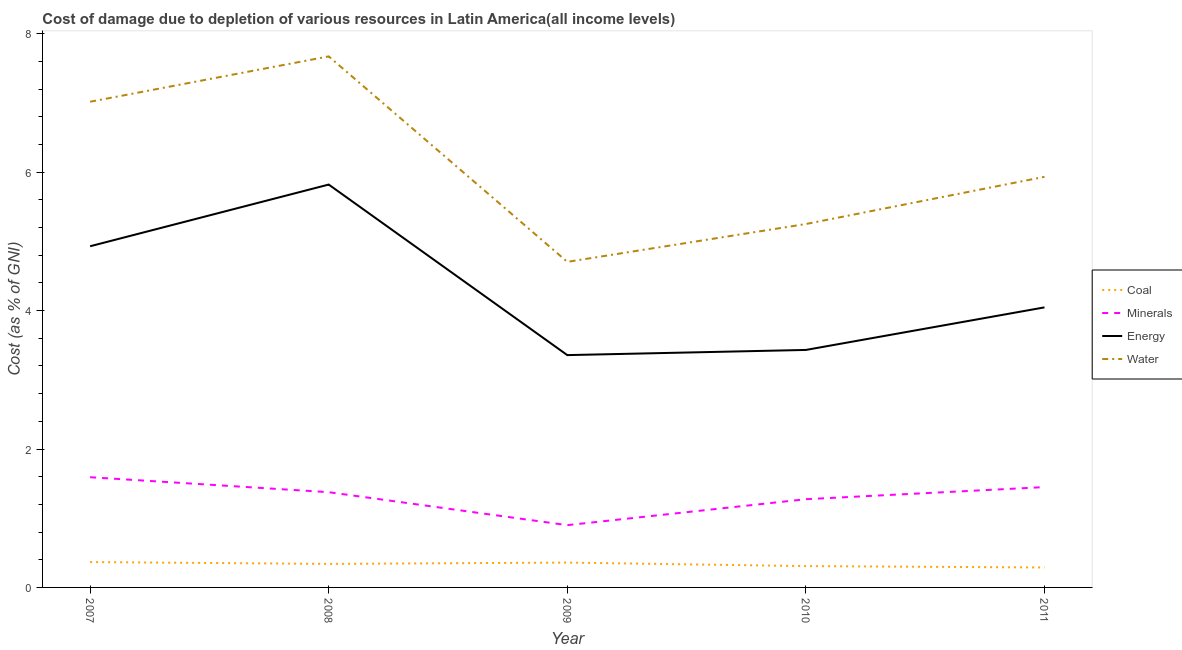How many different coloured lines are there?
Your answer should be very brief. 4. Does the line corresponding to cost of damage due to depletion of water intersect with the line corresponding to cost of damage due to depletion of energy?
Offer a very short reply. No. Is the number of lines equal to the number of legend labels?
Your answer should be compact. Yes. What is the cost of damage due to depletion of energy in 2009?
Offer a very short reply. 3.36. Across all years, what is the maximum cost of damage due to depletion of water?
Offer a terse response. 7.67. Across all years, what is the minimum cost of damage due to depletion of water?
Provide a short and direct response. 4.7. In which year was the cost of damage due to depletion of water minimum?
Make the answer very short. 2009. What is the total cost of damage due to depletion of water in the graph?
Ensure brevity in your answer.  30.58. What is the difference between the cost of damage due to depletion of coal in 2008 and that in 2009?
Your answer should be compact. -0.02. What is the difference between the cost of damage due to depletion of water in 2011 and the cost of damage due to depletion of coal in 2007?
Your answer should be compact. 5.57. What is the average cost of damage due to depletion of water per year?
Your answer should be compact. 6.12. In the year 2008, what is the difference between the cost of damage due to depletion of coal and cost of damage due to depletion of minerals?
Give a very brief answer. -1.04. In how many years, is the cost of damage due to depletion of coal greater than 6.4 %?
Your answer should be very brief. 0. What is the ratio of the cost of damage due to depletion of energy in 2010 to that in 2011?
Provide a succinct answer. 0.85. What is the difference between the highest and the second highest cost of damage due to depletion of energy?
Give a very brief answer. 0.89. What is the difference between the highest and the lowest cost of damage due to depletion of water?
Offer a very short reply. 2.97. In how many years, is the cost of damage due to depletion of coal greater than the average cost of damage due to depletion of coal taken over all years?
Your answer should be compact. 3. Is it the case that in every year, the sum of the cost of damage due to depletion of minerals and cost of damage due to depletion of water is greater than the sum of cost of damage due to depletion of energy and cost of damage due to depletion of coal?
Ensure brevity in your answer.  Yes. Is it the case that in every year, the sum of the cost of damage due to depletion of coal and cost of damage due to depletion of minerals is greater than the cost of damage due to depletion of energy?
Your answer should be very brief. No. Does the cost of damage due to depletion of energy monotonically increase over the years?
Offer a very short reply. No. Is the cost of damage due to depletion of energy strictly less than the cost of damage due to depletion of coal over the years?
Your response must be concise. No. How many lines are there?
Your answer should be very brief. 4. Are the values on the major ticks of Y-axis written in scientific E-notation?
Your answer should be compact. No. Does the graph contain any zero values?
Your answer should be compact. No. Does the graph contain grids?
Provide a succinct answer. No. Where does the legend appear in the graph?
Ensure brevity in your answer.  Center right. How many legend labels are there?
Offer a very short reply. 4. What is the title of the graph?
Provide a short and direct response. Cost of damage due to depletion of various resources in Latin America(all income levels) . Does "Environmental sustainability" appear as one of the legend labels in the graph?
Make the answer very short. No. What is the label or title of the Y-axis?
Your answer should be compact. Cost (as % of GNI). What is the Cost (as % of GNI) in Coal in 2007?
Your response must be concise. 0.37. What is the Cost (as % of GNI) in Minerals in 2007?
Your answer should be very brief. 1.59. What is the Cost (as % of GNI) of Energy in 2007?
Your answer should be very brief. 4.93. What is the Cost (as % of GNI) of Water in 2007?
Offer a terse response. 7.02. What is the Cost (as % of GNI) in Coal in 2008?
Offer a very short reply. 0.34. What is the Cost (as % of GNI) of Minerals in 2008?
Provide a succinct answer. 1.38. What is the Cost (as % of GNI) of Energy in 2008?
Your answer should be compact. 5.82. What is the Cost (as % of GNI) of Water in 2008?
Keep it short and to the point. 7.67. What is the Cost (as % of GNI) in Coal in 2009?
Offer a terse response. 0.36. What is the Cost (as % of GNI) in Minerals in 2009?
Provide a short and direct response. 0.9. What is the Cost (as % of GNI) in Energy in 2009?
Offer a very short reply. 3.36. What is the Cost (as % of GNI) of Water in 2009?
Your answer should be compact. 4.7. What is the Cost (as % of GNI) in Coal in 2010?
Provide a succinct answer. 0.31. What is the Cost (as % of GNI) in Minerals in 2010?
Offer a terse response. 1.27. What is the Cost (as % of GNI) of Energy in 2010?
Ensure brevity in your answer.  3.43. What is the Cost (as % of GNI) of Water in 2010?
Make the answer very short. 5.25. What is the Cost (as % of GNI) in Coal in 2011?
Ensure brevity in your answer.  0.29. What is the Cost (as % of GNI) of Minerals in 2011?
Ensure brevity in your answer.  1.45. What is the Cost (as % of GNI) in Energy in 2011?
Make the answer very short. 4.05. What is the Cost (as % of GNI) of Water in 2011?
Ensure brevity in your answer.  5.93. Across all years, what is the maximum Cost (as % of GNI) in Coal?
Keep it short and to the point. 0.37. Across all years, what is the maximum Cost (as % of GNI) of Minerals?
Ensure brevity in your answer.  1.59. Across all years, what is the maximum Cost (as % of GNI) in Energy?
Provide a short and direct response. 5.82. Across all years, what is the maximum Cost (as % of GNI) of Water?
Provide a succinct answer. 7.67. Across all years, what is the minimum Cost (as % of GNI) in Coal?
Your response must be concise. 0.29. Across all years, what is the minimum Cost (as % of GNI) of Minerals?
Your answer should be compact. 0.9. Across all years, what is the minimum Cost (as % of GNI) of Energy?
Your response must be concise. 3.36. Across all years, what is the minimum Cost (as % of GNI) of Water?
Your response must be concise. 4.7. What is the total Cost (as % of GNI) of Coal in the graph?
Keep it short and to the point. 1.66. What is the total Cost (as % of GNI) in Minerals in the graph?
Offer a terse response. 6.59. What is the total Cost (as % of GNI) in Energy in the graph?
Make the answer very short. 21.58. What is the total Cost (as % of GNI) of Water in the graph?
Make the answer very short. 30.58. What is the difference between the Cost (as % of GNI) of Coal in 2007 and that in 2008?
Keep it short and to the point. 0.03. What is the difference between the Cost (as % of GNI) of Minerals in 2007 and that in 2008?
Your answer should be compact. 0.22. What is the difference between the Cost (as % of GNI) of Energy in 2007 and that in 2008?
Keep it short and to the point. -0.89. What is the difference between the Cost (as % of GNI) in Water in 2007 and that in 2008?
Your response must be concise. -0.66. What is the difference between the Cost (as % of GNI) of Coal in 2007 and that in 2009?
Offer a terse response. 0.01. What is the difference between the Cost (as % of GNI) in Minerals in 2007 and that in 2009?
Make the answer very short. 0.69. What is the difference between the Cost (as % of GNI) of Energy in 2007 and that in 2009?
Your answer should be very brief. 1.57. What is the difference between the Cost (as % of GNI) of Water in 2007 and that in 2009?
Offer a very short reply. 2.31. What is the difference between the Cost (as % of GNI) of Coal in 2007 and that in 2010?
Your response must be concise. 0.06. What is the difference between the Cost (as % of GNI) in Minerals in 2007 and that in 2010?
Your answer should be compact. 0.32. What is the difference between the Cost (as % of GNI) in Energy in 2007 and that in 2010?
Your answer should be very brief. 1.5. What is the difference between the Cost (as % of GNI) of Water in 2007 and that in 2010?
Give a very brief answer. 1.77. What is the difference between the Cost (as % of GNI) in Coal in 2007 and that in 2011?
Provide a succinct answer. 0.08. What is the difference between the Cost (as % of GNI) of Minerals in 2007 and that in 2011?
Your answer should be compact. 0.14. What is the difference between the Cost (as % of GNI) of Energy in 2007 and that in 2011?
Make the answer very short. 0.88. What is the difference between the Cost (as % of GNI) in Water in 2007 and that in 2011?
Your response must be concise. 1.08. What is the difference between the Cost (as % of GNI) of Coal in 2008 and that in 2009?
Your answer should be very brief. -0.02. What is the difference between the Cost (as % of GNI) in Minerals in 2008 and that in 2009?
Offer a terse response. 0.48. What is the difference between the Cost (as % of GNI) in Energy in 2008 and that in 2009?
Ensure brevity in your answer.  2.46. What is the difference between the Cost (as % of GNI) of Water in 2008 and that in 2009?
Provide a short and direct response. 2.97. What is the difference between the Cost (as % of GNI) of Coal in 2008 and that in 2010?
Provide a short and direct response. 0.03. What is the difference between the Cost (as % of GNI) in Minerals in 2008 and that in 2010?
Offer a terse response. 0.1. What is the difference between the Cost (as % of GNI) of Energy in 2008 and that in 2010?
Keep it short and to the point. 2.39. What is the difference between the Cost (as % of GNI) in Water in 2008 and that in 2010?
Give a very brief answer. 2.42. What is the difference between the Cost (as % of GNI) in Coal in 2008 and that in 2011?
Give a very brief answer. 0.05. What is the difference between the Cost (as % of GNI) of Minerals in 2008 and that in 2011?
Ensure brevity in your answer.  -0.07. What is the difference between the Cost (as % of GNI) in Energy in 2008 and that in 2011?
Keep it short and to the point. 1.77. What is the difference between the Cost (as % of GNI) in Water in 2008 and that in 2011?
Give a very brief answer. 1.74. What is the difference between the Cost (as % of GNI) of Coal in 2009 and that in 2010?
Keep it short and to the point. 0.05. What is the difference between the Cost (as % of GNI) of Minerals in 2009 and that in 2010?
Your answer should be compact. -0.38. What is the difference between the Cost (as % of GNI) of Energy in 2009 and that in 2010?
Your answer should be compact. -0.07. What is the difference between the Cost (as % of GNI) in Water in 2009 and that in 2010?
Your response must be concise. -0.55. What is the difference between the Cost (as % of GNI) of Coal in 2009 and that in 2011?
Offer a terse response. 0.07. What is the difference between the Cost (as % of GNI) of Minerals in 2009 and that in 2011?
Your answer should be compact. -0.55. What is the difference between the Cost (as % of GNI) of Energy in 2009 and that in 2011?
Give a very brief answer. -0.69. What is the difference between the Cost (as % of GNI) in Water in 2009 and that in 2011?
Your answer should be very brief. -1.23. What is the difference between the Cost (as % of GNI) in Coal in 2010 and that in 2011?
Your answer should be very brief. 0.02. What is the difference between the Cost (as % of GNI) of Minerals in 2010 and that in 2011?
Your answer should be compact. -0.17. What is the difference between the Cost (as % of GNI) in Energy in 2010 and that in 2011?
Your answer should be compact. -0.61. What is the difference between the Cost (as % of GNI) in Water in 2010 and that in 2011?
Your response must be concise. -0.68. What is the difference between the Cost (as % of GNI) in Coal in 2007 and the Cost (as % of GNI) in Minerals in 2008?
Give a very brief answer. -1.01. What is the difference between the Cost (as % of GNI) in Coal in 2007 and the Cost (as % of GNI) in Energy in 2008?
Keep it short and to the point. -5.45. What is the difference between the Cost (as % of GNI) of Coal in 2007 and the Cost (as % of GNI) of Water in 2008?
Give a very brief answer. -7.31. What is the difference between the Cost (as % of GNI) of Minerals in 2007 and the Cost (as % of GNI) of Energy in 2008?
Your answer should be very brief. -4.23. What is the difference between the Cost (as % of GNI) of Minerals in 2007 and the Cost (as % of GNI) of Water in 2008?
Ensure brevity in your answer.  -6.08. What is the difference between the Cost (as % of GNI) of Energy in 2007 and the Cost (as % of GNI) of Water in 2008?
Offer a terse response. -2.74. What is the difference between the Cost (as % of GNI) in Coal in 2007 and the Cost (as % of GNI) in Minerals in 2009?
Offer a terse response. -0.53. What is the difference between the Cost (as % of GNI) in Coal in 2007 and the Cost (as % of GNI) in Energy in 2009?
Your response must be concise. -2.99. What is the difference between the Cost (as % of GNI) of Coal in 2007 and the Cost (as % of GNI) of Water in 2009?
Provide a short and direct response. -4.34. What is the difference between the Cost (as % of GNI) in Minerals in 2007 and the Cost (as % of GNI) in Energy in 2009?
Your answer should be very brief. -1.76. What is the difference between the Cost (as % of GNI) in Minerals in 2007 and the Cost (as % of GNI) in Water in 2009?
Give a very brief answer. -3.11. What is the difference between the Cost (as % of GNI) of Energy in 2007 and the Cost (as % of GNI) of Water in 2009?
Offer a terse response. 0.23. What is the difference between the Cost (as % of GNI) in Coal in 2007 and the Cost (as % of GNI) in Minerals in 2010?
Your answer should be very brief. -0.91. What is the difference between the Cost (as % of GNI) of Coal in 2007 and the Cost (as % of GNI) of Energy in 2010?
Offer a very short reply. -3.07. What is the difference between the Cost (as % of GNI) in Coal in 2007 and the Cost (as % of GNI) in Water in 2010?
Your answer should be very brief. -4.88. What is the difference between the Cost (as % of GNI) of Minerals in 2007 and the Cost (as % of GNI) of Energy in 2010?
Keep it short and to the point. -1.84. What is the difference between the Cost (as % of GNI) of Minerals in 2007 and the Cost (as % of GNI) of Water in 2010?
Offer a very short reply. -3.66. What is the difference between the Cost (as % of GNI) of Energy in 2007 and the Cost (as % of GNI) of Water in 2010?
Ensure brevity in your answer.  -0.32. What is the difference between the Cost (as % of GNI) in Coal in 2007 and the Cost (as % of GNI) in Minerals in 2011?
Offer a terse response. -1.08. What is the difference between the Cost (as % of GNI) of Coal in 2007 and the Cost (as % of GNI) of Energy in 2011?
Ensure brevity in your answer.  -3.68. What is the difference between the Cost (as % of GNI) in Coal in 2007 and the Cost (as % of GNI) in Water in 2011?
Your response must be concise. -5.57. What is the difference between the Cost (as % of GNI) of Minerals in 2007 and the Cost (as % of GNI) of Energy in 2011?
Provide a succinct answer. -2.45. What is the difference between the Cost (as % of GNI) of Minerals in 2007 and the Cost (as % of GNI) of Water in 2011?
Offer a terse response. -4.34. What is the difference between the Cost (as % of GNI) of Energy in 2007 and the Cost (as % of GNI) of Water in 2011?
Your response must be concise. -1. What is the difference between the Cost (as % of GNI) in Coal in 2008 and the Cost (as % of GNI) in Minerals in 2009?
Make the answer very short. -0.56. What is the difference between the Cost (as % of GNI) of Coal in 2008 and the Cost (as % of GNI) of Energy in 2009?
Provide a succinct answer. -3.02. What is the difference between the Cost (as % of GNI) of Coal in 2008 and the Cost (as % of GNI) of Water in 2009?
Your answer should be compact. -4.36. What is the difference between the Cost (as % of GNI) of Minerals in 2008 and the Cost (as % of GNI) of Energy in 2009?
Provide a succinct answer. -1.98. What is the difference between the Cost (as % of GNI) of Minerals in 2008 and the Cost (as % of GNI) of Water in 2009?
Ensure brevity in your answer.  -3.33. What is the difference between the Cost (as % of GNI) of Energy in 2008 and the Cost (as % of GNI) of Water in 2009?
Offer a terse response. 1.12. What is the difference between the Cost (as % of GNI) in Coal in 2008 and the Cost (as % of GNI) in Minerals in 2010?
Your answer should be very brief. -0.94. What is the difference between the Cost (as % of GNI) of Coal in 2008 and the Cost (as % of GNI) of Energy in 2010?
Give a very brief answer. -3.09. What is the difference between the Cost (as % of GNI) in Coal in 2008 and the Cost (as % of GNI) in Water in 2010?
Give a very brief answer. -4.91. What is the difference between the Cost (as % of GNI) in Minerals in 2008 and the Cost (as % of GNI) in Energy in 2010?
Provide a short and direct response. -2.06. What is the difference between the Cost (as % of GNI) in Minerals in 2008 and the Cost (as % of GNI) in Water in 2010?
Provide a succinct answer. -3.87. What is the difference between the Cost (as % of GNI) of Energy in 2008 and the Cost (as % of GNI) of Water in 2010?
Make the answer very short. 0.57. What is the difference between the Cost (as % of GNI) of Coal in 2008 and the Cost (as % of GNI) of Minerals in 2011?
Offer a very short reply. -1.11. What is the difference between the Cost (as % of GNI) in Coal in 2008 and the Cost (as % of GNI) in Energy in 2011?
Keep it short and to the point. -3.71. What is the difference between the Cost (as % of GNI) of Coal in 2008 and the Cost (as % of GNI) of Water in 2011?
Keep it short and to the point. -5.59. What is the difference between the Cost (as % of GNI) in Minerals in 2008 and the Cost (as % of GNI) in Energy in 2011?
Keep it short and to the point. -2.67. What is the difference between the Cost (as % of GNI) of Minerals in 2008 and the Cost (as % of GNI) of Water in 2011?
Provide a short and direct response. -4.56. What is the difference between the Cost (as % of GNI) of Energy in 2008 and the Cost (as % of GNI) of Water in 2011?
Provide a succinct answer. -0.11. What is the difference between the Cost (as % of GNI) in Coal in 2009 and the Cost (as % of GNI) in Minerals in 2010?
Ensure brevity in your answer.  -0.92. What is the difference between the Cost (as % of GNI) of Coal in 2009 and the Cost (as % of GNI) of Energy in 2010?
Provide a short and direct response. -3.07. What is the difference between the Cost (as % of GNI) of Coal in 2009 and the Cost (as % of GNI) of Water in 2010?
Give a very brief answer. -4.89. What is the difference between the Cost (as % of GNI) of Minerals in 2009 and the Cost (as % of GNI) of Energy in 2010?
Offer a terse response. -2.53. What is the difference between the Cost (as % of GNI) of Minerals in 2009 and the Cost (as % of GNI) of Water in 2010?
Ensure brevity in your answer.  -4.35. What is the difference between the Cost (as % of GNI) of Energy in 2009 and the Cost (as % of GNI) of Water in 2010?
Give a very brief answer. -1.89. What is the difference between the Cost (as % of GNI) of Coal in 2009 and the Cost (as % of GNI) of Minerals in 2011?
Ensure brevity in your answer.  -1.09. What is the difference between the Cost (as % of GNI) in Coal in 2009 and the Cost (as % of GNI) in Energy in 2011?
Keep it short and to the point. -3.69. What is the difference between the Cost (as % of GNI) of Coal in 2009 and the Cost (as % of GNI) of Water in 2011?
Offer a terse response. -5.57. What is the difference between the Cost (as % of GNI) in Minerals in 2009 and the Cost (as % of GNI) in Energy in 2011?
Offer a very short reply. -3.15. What is the difference between the Cost (as % of GNI) of Minerals in 2009 and the Cost (as % of GNI) of Water in 2011?
Ensure brevity in your answer.  -5.03. What is the difference between the Cost (as % of GNI) of Energy in 2009 and the Cost (as % of GNI) of Water in 2011?
Make the answer very short. -2.58. What is the difference between the Cost (as % of GNI) of Coal in 2010 and the Cost (as % of GNI) of Minerals in 2011?
Provide a succinct answer. -1.14. What is the difference between the Cost (as % of GNI) of Coal in 2010 and the Cost (as % of GNI) of Energy in 2011?
Provide a succinct answer. -3.74. What is the difference between the Cost (as % of GNI) in Coal in 2010 and the Cost (as % of GNI) in Water in 2011?
Your response must be concise. -5.62. What is the difference between the Cost (as % of GNI) of Minerals in 2010 and the Cost (as % of GNI) of Energy in 2011?
Ensure brevity in your answer.  -2.77. What is the difference between the Cost (as % of GNI) of Minerals in 2010 and the Cost (as % of GNI) of Water in 2011?
Provide a succinct answer. -4.66. What is the difference between the Cost (as % of GNI) of Energy in 2010 and the Cost (as % of GNI) of Water in 2011?
Give a very brief answer. -2.5. What is the average Cost (as % of GNI) in Coal per year?
Give a very brief answer. 0.33. What is the average Cost (as % of GNI) in Minerals per year?
Give a very brief answer. 1.32. What is the average Cost (as % of GNI) of Energy per year?
Your answer should be compact. 4.32. What is the average Cost (as % of GNI) of Water per year?
Keep it short and to the point. 6.12. In the year 2007, what is the difference between the Cost (as % of GNI) of Coal and Cost (as % of GNI) of Minerals?
Provide a succinct answer. -1.23. In the year 2007, what is the difference between the Cost (as % of GNI) of Coal and Cost (as % of GNI) of Energy?
Keep it short and to the point. -4.56. In the year 2007, what is the difference between the Cost (as % of GNI) of Coal and Cost (as % of GNI) of Water?
Your answer should be very brief. -6.65. In the year 2007, what is the difference between the Cost (as % of GNI) in Minerals and Cost (as % of GNI) in Energy?
Your answer should be very brief. -3.34. In the year 2007, what is the difference between the Cost (as % of GNI) of Minerals and Cost (as % of GNI) of Water?
Keep it short and to the point. -5.42. In the year 2007, what is the difference between the Cost (as % of GNI) of Energy and Cost (as % of GNI) of Water?
Your answer should be compact. -2.09. In the year 2008, what is the difference between the Cost (as % of GNI) in Coal and Cost (as % of GNI) in Minerals?
Provide a succinct answer. -1.04. In the year 2008, what is the difference between the Cost (as % of GNI) in Coal and Cost (as % of GNI) in Energy?
Keep it short and to the point. -5.48. In the year 2008, what is the difference between the Cost (as % of GNI) of Coal and Cost (as % of GNI) of Water?
Keep it short and to the point. -7.33. In the year 2008, what is the difference between the Cost (as % of GNI) in Minerals and Cost (as % of GNI) in Energy?
Give a very brief answer. -4.44. In the year 2008, what is the difference between the Cost (as % of GNI) in Minerals and Cost (as % of GNI) in Water?
Your answer should be very brief. -6.3. In the year 2008, what is the difference between the Cost (as % of GNI) of Energy and Cost (as % of GNI) of Water?
Offer a very short reply. -1.85. In the year 2009, what is the difference between the Cost (as % of GNI) of Coal and Cost (as % of GNI) of Minerals?
Give a very brief answer. -0.54. In the year 2009, what is the difference between the Cost (as % of GNI) in Coal and Cost (as % of GNI) in Energy?
Your answer should be very brief. -3. In the year 2009, what is the difference between the Cost (as % of GNI) in Coal and Cost (as % of GNI) in Water?
Provide a succinct answer. -4.34. In the year 2009, what is the difference between the Cost (as % of GNI) in Minerals and Cost (as % of GNI) in Energy?
Your answer should be very brief. -2.46. In the year 2009, what is the difference between the Cost (as % of GNI) of Minerals and Cost (as % of GNI) of Water?
Your answer should be very brief. -3.8. In the year 2009, what is the difference between the Cost (as % of GNI) in Energy and Cost (as % of GNI) in Water?
Your answer should be compact. -1.35. In the year 2010, what is the difference between the Cost (as % of GNI) of Coal and Cost (as % of GNI) of Minerals?
Give a very brief answer. -0.97. In the year 2010, what is the difference between the Cost (as % of GNI) of Coal and Cost (as % of GNI) of Energy?
Keep it short and to the point. -3.12. In the year 2010, what is the difference between the Cost (as % of GNI) of Coal and Cost (as % of GNI) of Water?
Provide a succinct answer. -4.94. In the year 2010, what is the difference between the Cost (as % of GNI) of Minerals and Cost (as % of GNI) of Energy?
Ensure brevity in your answer.  -2.16. In the year 2010, what is the difference between the Cost (as % of GNI) in Minerals and Cost (as % of GNI) in Water?
Offer a very short reply. -3.98. In the year 2010, what is the difference between the Cost (as % of GNI) in Energy and Cost (as % of GNI) in Water?
Provide a succinct answer. -1.82. In the year 2011, what is the difference between the Cost (as % of GNI) in Coal and Cost (as % of GNI) in Minerals?
Offer a terse response. -1.16. In the year 2011, what is the difference between the Cost (as % of GNI) of Coal and Cost (as % of GNI) of Energy?
Provide a succinct answer. -3.76. In the year 2011, what is the difference between the Cost (as % of GNI) of Coal and Cost (as % of GNI) of Water?
Provide a short and direct response. -5.64. In the year 2011, what is the difference between the Cost (as % of GNI) in Minerals and Cost (as % of GNI) in Energy?
Provide a short and direct response. -2.6. In the year 2011, what is the difference between the Cost (as % of GNI) in Minerals and Cost (as % of GNI) in Water?
Offer a very short reply. -4.48. In the year 2011, what is the difference between the Cost (as % of GNI) in Energy and Cost (as % of GNI) in Water?
Offer a terse response. -1.89. What is the ratio of the Cost (as % of GNI) of Coal in 2007 to that in 2008?
Give a very brief answer. 1.08. What is the ratio of the Cost (as % of GNI) in Minerals in 2007 to that in 2008?
Make the answer very short. 1.16. What is the ratio of the Cost (as % of GNI) of Energy in 2007 to that in 2008?
Give a very brief answer. 0.85. What is the ratio of the Cost (as % of GNI) of Water in 2007 to that in 2008?
Your answer should be compact. 0.91. What is the ratio of the Cost (as % of GNI) of Coal in 2007 to that in 2009?
Keep it short and to the point. 1.02. What is the ratio of the Cost (as % of GNI) in Minerals in 2007 to that in 2009?
Your answer should be compact. 1.77. What is the ratio of the Cost (as % of GNI) in Energy in 2007 to that in 2009?
Your answer should be very brief. 1.47. What is the ratio of the Cost (as % of GNI) in Water in 2007 to that in 2009?
Your answer should be compact. 1.49. What is the ratio of the Cost (as % of GNI) in Coal in 2007 to that in 2010?
Ensure brevity in your answer.  1.19. What is the ratio of the Cost (as % of GNI) of Minerals in 2007 to that in 2010?
Give a very brief answer. 1.25. What is the ratio of the Cost (as % of GNI) in Energy in 2007 to that in 2010?
Offer a very short reply. 1.44. What is the ratio of the Cost (as % of GNI) of Water in 2007 to that in 2010?
Offer a terse response. 1.34. What is the ratio of the Cost (as % of GNI) of Coal in 2007 to that in 2011?
Provide a succinct answer. 1.27. What is the ratio of the Cost (as % of GNI) of Minerals in 2007 to that in 2011?
Offer a very short reply. 1.1. What is the ratio of the Cost (as % of GNI) in Energy in 2007 to that in 2011?
Offer a very short reply. 1.22. What is the ratio of the Cost (as % of GNI) of Water in 2007 to that in 2011?
Your answer should be very brief. 1.18. What is the ratio of the Cost (as % of GNI) of Coal in 2008 to that in 2009?
Keep it short and to the point. 0.95. What is the ratio of the Cost (as % of GNI) in Minerals in 2008 to that in 2009?
Your response must be concise. 1.53. What is the ratio of the Cost (as % of GNI) in Energy in 2008 to that in 2009?
Provide a short and direct response. 1.73. What is the ratio of the Cost (as % of GNI) of Water in 2008 to that in 2009?
Your response must be concise. 1.63. What is the ratio of the Cost (as % of GNI) of Coal in 2008 to that in 2010?
Give a very brief answer. 1.1. What is the ratio of the Cost (as % of GNI) of Minerals in 2008 to that in 2010?
Provide a succinct answer. 1.08. What is the ratio of the Cost (as % of GNI) in Energy in 2008 to that in 2010?
Provide a succinct answer. 1.7. What is the ratio of the Cost (as % of GNI) of Water in 2008 to that in 2010?
Your response must be concise. 1.46. What is the ratio of the Cost (as % of GNI) of Coal in 2008 to that in 2011?
Your answer should be very brief. 1.18. What is the ratio of the Cost (as % of GNI) of Minerals in 2008 to that in 2011?
Provide a succinct answer. 0.95. What is the ratio of the Cost (as % of GNI) in Energy in 2008 to that in 2011?
Your response must be concise. 1.44. What is the ratio of the Cost (as % of GNI) of Water in 2008 to that in 2011?
Offer a very short reply. 1.29. What is the ratio of the Cost (as % of GNI) of Coal in 2009 to that in 2010?
Provide a succinct answer. 1.17. What is the ratio of the Cost (as % of GNI) in Minerals in 2009 to that in 2010?
Keep it short and to the point. 0.71. What is the ratio of the Cost (as % of GNI) of Energy in 2009 to that in 2010?
Ensure brevity in your answer.  0.98. What is the ratio of the Cost (as % of GNI) of Water in 2009 to that in 2010?
Make the answer very short. 0.9. What is the ratio of the Cost (as % of GNI) in Coal in 2009 to that in 2011?
Provide a succinct answer. 1.25. What is the ratio of the Cost (as % of GNI) in Minerals in 2009 to that in 2011?
Give a very brief answer. 0.62. What is the ratio of the Cost (as % of GNI) of Energy in 2009 to that in 2011?
Provide a short and direct response. 0.83. What is the ratio of the Cost (as % of GNI) in Water in 2009 to that in 2011?
Keep it short and to the point. 0.79. What is the ratio of the Cost (as % of GNI) of Coal in 2010 to that in 2011?
Give a very brief answer. 1.07. What is the ratio of the Cost (as % of GNI) of Minerals in 2010 to that in 2011?
Keep it short and to the point. 0.88. What is the ratio of the Cost (as % of GNI) in Energy in 2010 to that in 2011?
Your answer should be very brief. 0.85. What is the ratio of the Cost (as % of GNI) in Water in 2010 to that in 2011?
Offer a terse response. 0.89. What is the difference between the highest and the second highest Cost (as % of GNI) in Coal?
Offer a terse response. 0.01. What is the difference between the highest and the second highest Cost (as % of GNI) in Minerals?
Your response must be concise. 0.14. What is the difference between the highest and the second highest Cost (as % of GNI) in Energy?
Ensure brevity in your answer.  0.89. What is the difference between the highest and the second highest Cost (as % of GNI) of Water?
Your answer should be very brief. 0.66. What is the difference between the highest and the lowest Cost (as % of GNI) of Coal?
Your response must be concise. 0.08. What is the difference between the highest and the lowest Cost (as % of GNI) in Minerals?
Provide a succinct answer. 0.69. What is the difference between the highest and the lowest Cost (as % of GNI) in Energy?
Give a very brief answer. 2.46. What is the difference between the highest and the lowest Cost (as % of GNI) of Water?
Ensure brevity in your answer.  2.97. 